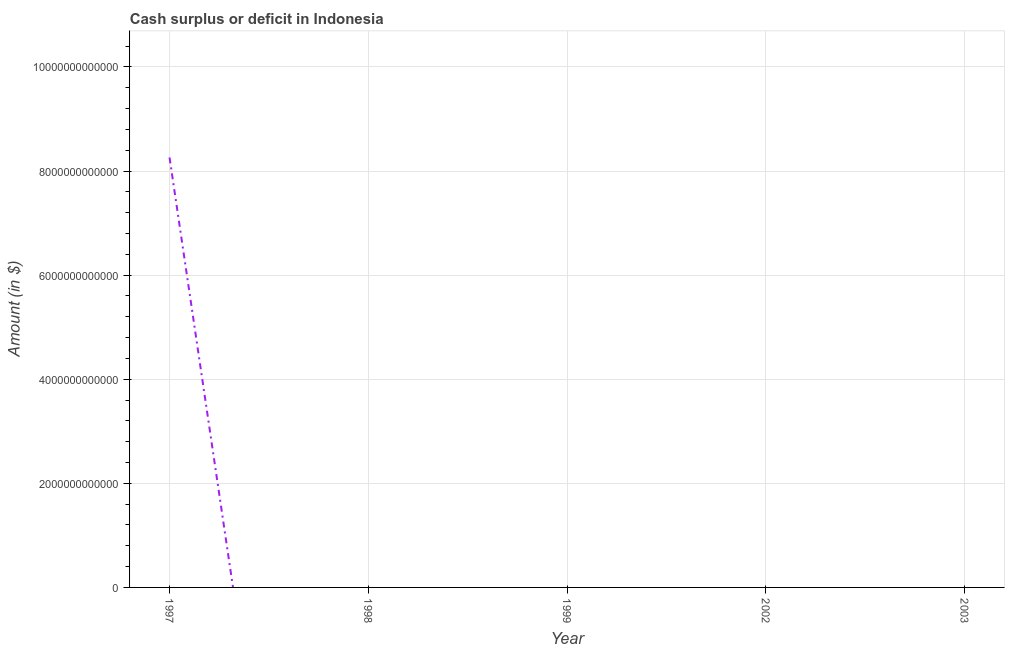What is the cash surplus or deficit in 1997?
Offer a very short reply. 8.26e+12. Across all years, what is the maximum cash surplus or deficit?
Your answer should be compact. 8.26e+12. Across all years, what is the minimum cash surplus or deficit?
Keep it short and to the point. 0. What is the sum of the cash surplus or deficit?
Keep it short and to the point. 8.26e+12. What is the average cash surplus or deficit per year?
Make the answer very short. 1.65e+12. What is the median cash surplus or deficit?
Your answer should be compact. 0. In how many years, is the cash surplus or deficit greater than 2000000000000 $?
Offer a very short reply. 1. What is the difference between the highest and the lowest cash surplus or deficit?
Keep it short and to the point. 8.26e+12. In how many years, is the cash surplus or deficit greater than the average cash surplus or deficit taken over all years?
Offer a very short reply. 1. Does the cash surplus or deficit monotonically increase over the years?
Make the answer very short. No. What is the difference between two consecutive major ticks on the Y-axis?
Your answer should be compact. 2.00e+12. Are the values on the major ticks of Y-axis written in scientific E-notation?
Give a very brief answer. No. Does the graph contain any zero values?
Provide a short and direct response. Yes. Does the graph contain grids?
Keep it short and to the point. Yes. What is the title of the graph?
Offer a very short reply. Cash surplus or deficit in Indonesia. What is the label or title of the Y-axis?
Ensure brevity in your answer.  Amount (in $). What is the Amount (in $) of 1997?
Provide a succinct answer. 8.26e+12. What is the Amount (in $) of 1999?
Your answer should be very brief. 0. 